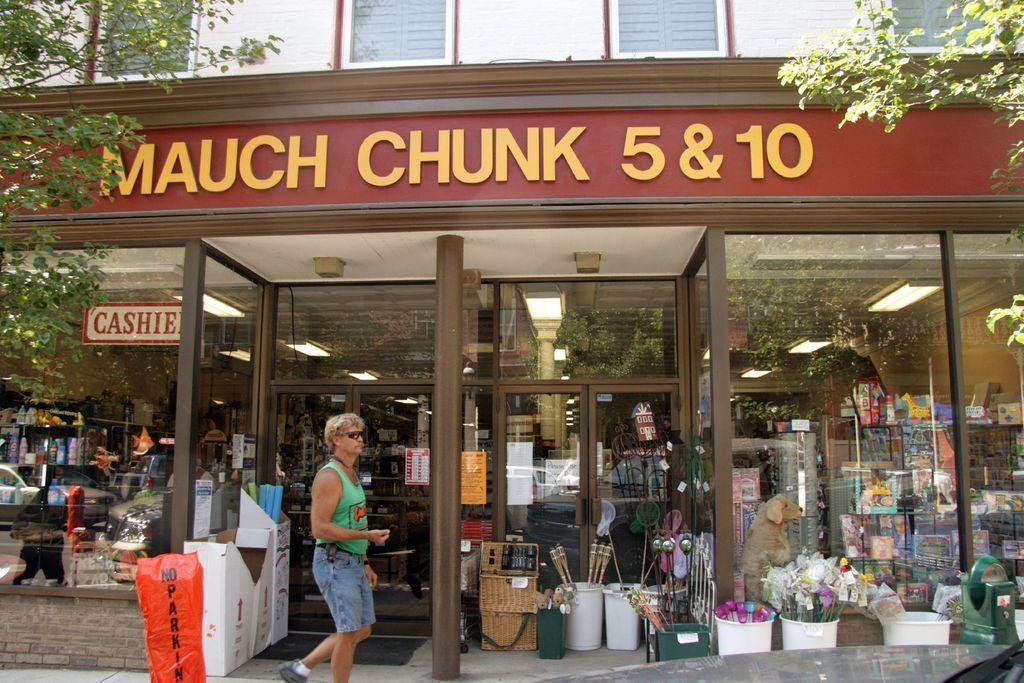Can you describe this image briefly? In this image there is a stall with some text on top of it, in front of the stall there are so many objects are in the plastic objects look like buckets are arranged on the pavement and there is a person walking. There is a glass wall of the stall through which we can see there are so many objects in the stall and there is a ceiling with lights. 